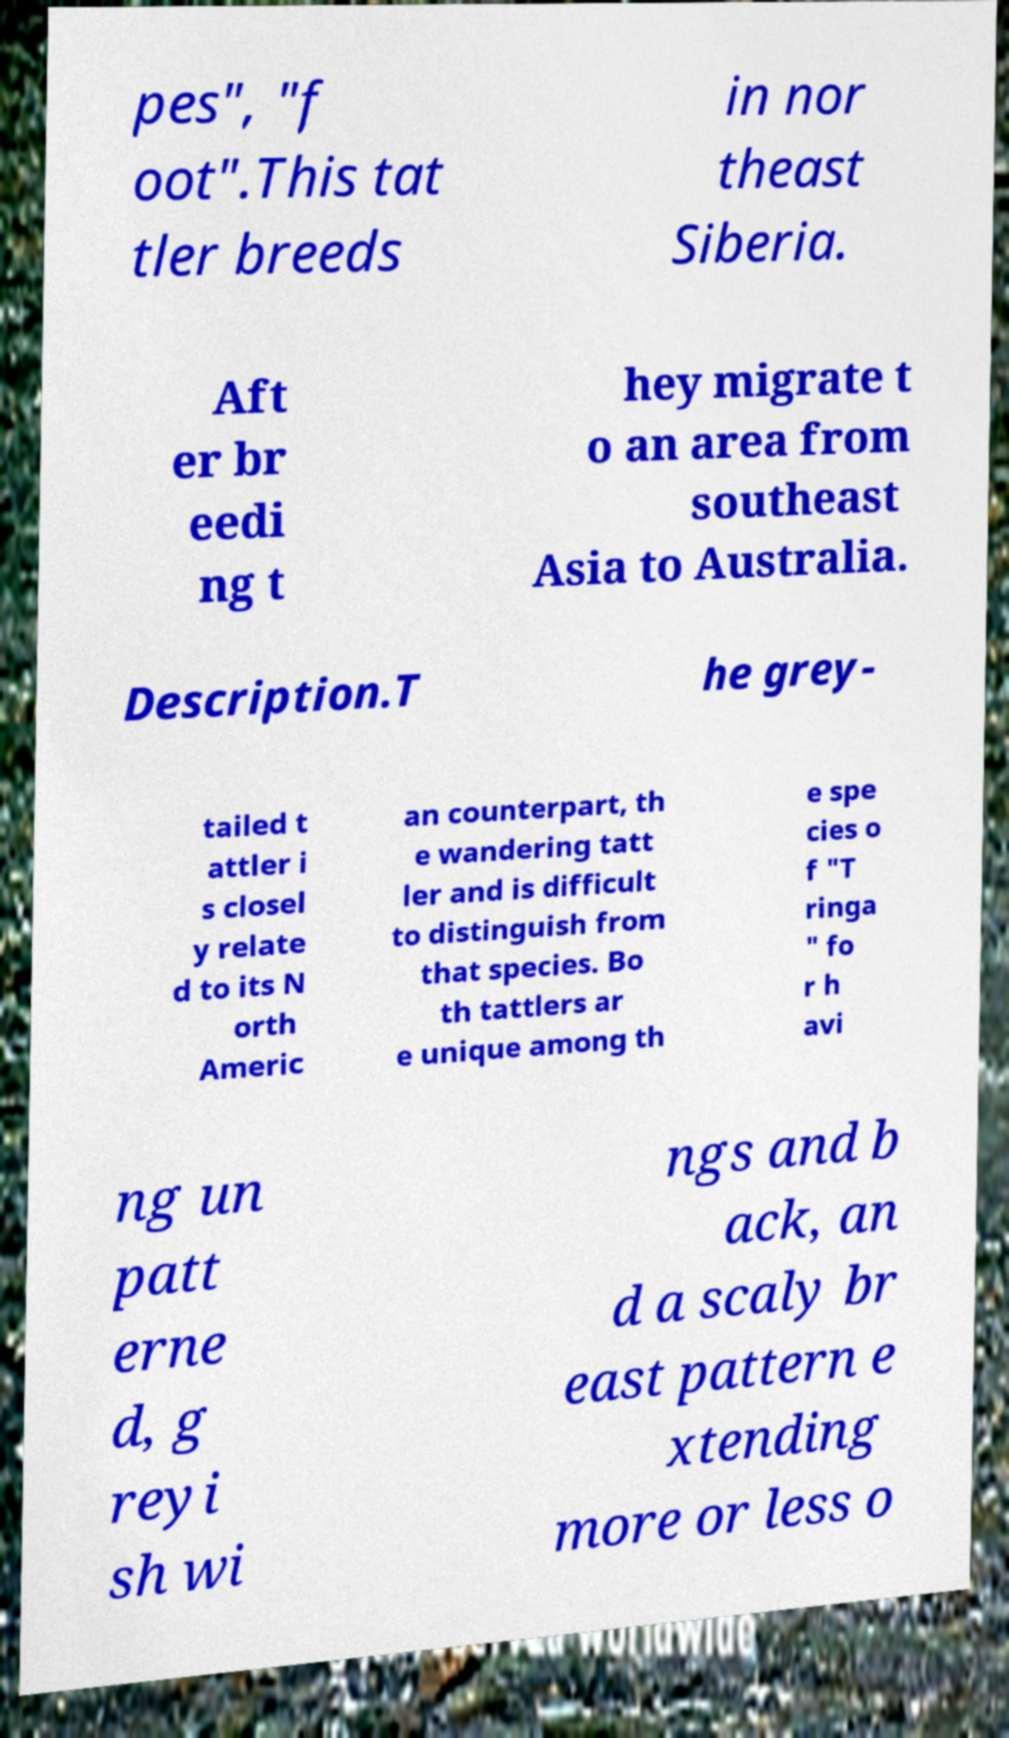Could you assist in decoding the text presented in this image and type it out clearly? pes", "f oot".This tat tler breeds in nor theast Siberia. Aft er br eedi ng t hey migrate t o an area from southeast Asia to Australia. Description.T he grey- tailed t attler i s closel y relate d to its N orth Americ an counterpart, th e wandering tatt ler and is difficult to distinguish from that species. Bo th tattlers ar e unique among th e spe cies o f "T ringa " fo r h avi ng un patt erne d, g reyi sh wi ngs and b ack, an d a scaly br east pattern e xtending more or less o 